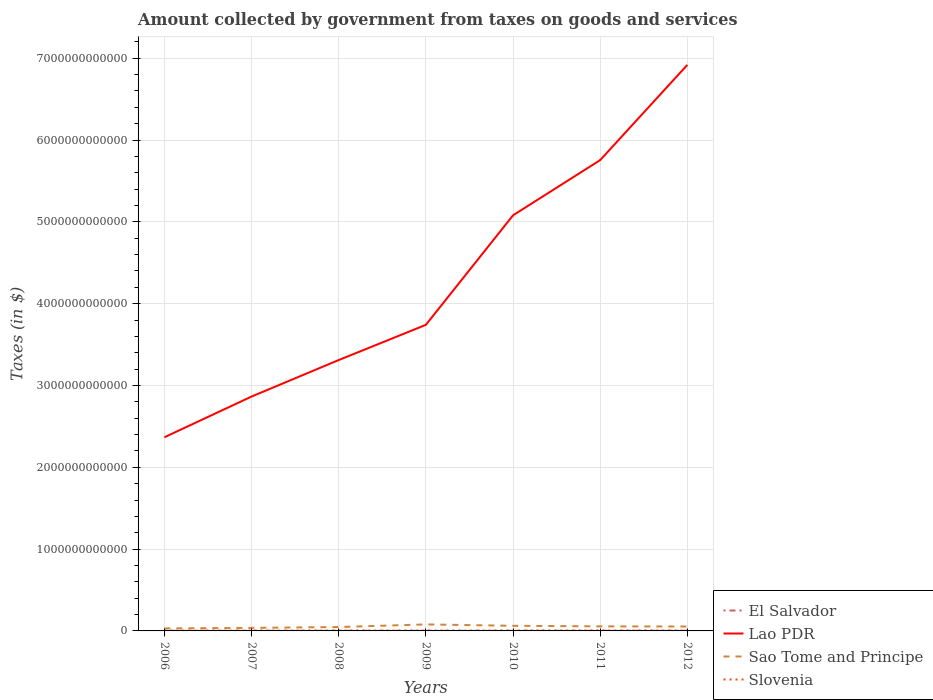How many different coloured lines are there?
Provide a short and direct response. 4. Does the line corresponding to Lao PDR intersect with the line corresponding to Slovenia?
Keep it short and to the point. No. Is the number of lines equal to the number of legend labels?
Your answer should be compact. Yes. Across all years, what is the maximum amount collected by government from taxes on goods and services in Slovenia?
Make the answer very short. 3.95e+09. What is the total amount collected by government from taxes on goods and services in Sao Tome and Principe in the graph?
Your answer should be compact. 2.57e+1. What is the difference between the highest and the second highest amount collected by government from taxes on goods and services in Slovenia?
Keep it short and to the point. 8.12e+08. How many lines are there?
Give a very brief answer. 4. How many years are there in the graph?
Keep it short and to the point. 7. What is the difference between two consecutive major ticks on the Y-axis?
Keep it short and to the point. 1.00e+12. Are the values on the major ticks of Y-axis written in scientific E-notation?
Your answer should be very brief. No. Does the graph contain any zero values?
Keep it short and to the point. No. Does the graph contain grids?
Make the answer very short. Yes. How many legend labels are there?
Your answer should be very brief. 4. What is the title of the graph?
Offer a terse response. Amount collected by government from taxes on goods and services. What is the label or title of the X-axis?
Your answer should be very brief. Years. What is the label or title of the Y-axis?
Keep it short and to the point. Taxes (in $). What is the Taxes (in $) in El Salvador in 2006?
Keep it short and to the point. 1.47e+09. What is the Taxes (in $) of Lao PDR in 2006?
Give a very brief answer. 2.37e+12. What is the Taxes (in $) in Sao Tome and Principe in 2006?
Your answer should be very brief. 3.05e+1. What is the Taxes (in $) in Slovenia in 2006?
Provide a succinct answer. 3.95e+09. What is the Taxes (in $) in El Salvador in 2007?
Offer a terse response. 1.66e+09. What is the Taxes (in $) in Lao PDR in 2007?
Your answer should be compact. 2.86e+12. What is the Taxes (in $) of Sao Tome and Principe in 2007?
Keep it short and to the point. 3.71e+1. What is the Taxes (in $) in Slovenia in 2007?
Your answer should be compact. 4.37e+09. What is the Taxes (in $) in El Salvador in 2008?
Make the answer very short. 1.80e+09. What is the Taxes (in $) in Lao PDR in 2008?
Keep it short and to the point. 3.31e+12. What is the Taxes (in $) in Sao Tome and Principe in 2008?
Give a very brief answer. 4.76e+1. What is the Taxes (in $) of Slovenia in 2008?
Offer a very short reply. 4.67e+09. What is the Taxes (in $) of El Salvador in 2009?
Keep it short and to the point. 1.44e+09. What is the Taxes (in $) in Lao PDR in 2009?
Give a very brief answer. 3.74e+12. What is the Taxes (in $) in Sao Tome and Principe in 2009?
Provide a succinct answer. 7.95e+1. What is the Taxes (in $) of Slovenia in 2009?
Your answer should be very brief. 4.54e+09. What is the Taxes (in $) of El Salvador in 2010?
Offer a very short reply. 1.66e+09. What is the Taxes (in $) of Lao PDR in 2010?
Keep it short and to the point. 5.08e+12. What is the Taxes (in $) of Sao Tome and Principe in 2010?
Provide a short and direct response. 6.27e+1. What is the Taxes (in $) of Slovenia in 2010?
Give a very brief answer. 4.66e+09. What is the Taxes (in $) of El Salvador in 2011?
Keep it short and to the point. 1.69e+09. What is the Taxes (in $) in Lao PDR in 2011?
Ensure brevity in your answer.  5.75e+12. What is the Taxes (in $) in Sao Tome and Principe in 2011?
Your answer should be compact. 5.56e+1. What is the Taxes (in $) of Slovenia in 2011?
Your answer should be very brief. 4.73e+09. What is the Taxes (in $) in El Salvador in 2012?
Your answer should be very brief. 2.09e+09. What is the Taxes (in $) of Lao PDR in 2012?
Give a very brief answer. 6.92e+12. What is the Taxes (in $) of Sao Tome and Principe in 2012?
Offer a very short reply. 5.38e+1. What is the Taxes (in $) of Slovenia in 2012?
Keep it short and to the point. 4.76e+09. Across all years, what is the maximum Taxes (in $) in El Salvador?
Your answer should be compact. 2.09e+09. Across all years, what is the maximum Taxes (in $) in Lao PDR?
Your answer should be compact. 6.92e+12. Across all years, what is the maximum Taxes (in $) of Sao Tome and Principe?
Your answer should be compact. 7.95e+1. Across all years, what is the maximum Taxes (in $) in Slovenia?
Your answer should be very brief. 4.76e+09. Across all years, what is the minimum Taxes (in $) in El Salvador?
Offer a very short reply. 1.44e+09. Across all years, what is the minimum Taxes (in $) of Lao PDR?
Your answer should be very brief. 2.37e+12. Across all years, what is the minimum Taxes (in $) of Sao Tome and Principe?
Offer a very short reply. 3.05e+1. Across all years, what is the minimum Taxes (in $) in Slovenia?
Your response must be concise. 3.95e+09. What is the total Taxes (in $) in El Salvador in the graph?
Provide a short and direct response. 1.18e+1. What is the total Taxes (in $) of Lao PDR in the graph?
Provide a short and direct response. 3.00e+13. What is the total Taxes (in $) in Sao Tome and Principe in the graph?
Provide a succinct answer. 3.67e+11. What is the total Taxes (in $) in Slovenia in the graph?
Provide a short and direct response. 3.17e+1. What is the difference between the Taxes (in $) of El Salvador in 2006 and that in 2007?
Ensure brevity in your answer.  -1.86e+08. What is the difference between the Taxes (in $) in Lao PDR in 2006 and that in 2007?
Provide a succinct answer. -4.98e+11. What is the difference between the Taxes (in $) in Sao Tome and Principe in 2006 and that in 2007?
Make the answer very short. -6.60e+09. What is the difference between the Taxes (in $) of Slovenia in 2006 and that in 2007?
Ensure brevity in your answer.  -4.23e+08. What is the difference between the Taxes (in $) of El Salvador in 2006 and that in 2008?
Your answer should be compact. -3.30e+08. What is the difference between the Taxes (in $) of Lao PDR in 2006 and that in 2008?
Your answer should be compact. -9.44e+11. What is the difference between the Taxes (in $) in Sao Tome and Principe in 2006 and that in 2008?
Offer a terse response. -1.71e+1. What is the difference between the Taxes (in $) of Slovenia in 2006 and that in 2008?
Your response must be concise. -7.19e+08. What is the difference between the Taxes (in $) of El Salvador in 2006 and that in 2009?
Offer a terse response. 3.19e+07. What is the difference between the Taxes (in $) in Lao PDR in 2006 and that in 2009?
Offer a very short reply. -1.37e+12. What is the difference between the Taxes (in $) of Sao Tome and Principe in 2006 and that in 2009?
Give a very brief answer. -4.90e+1. What is the difference between the Taxes (in $) in Slovenia in 2006 and that in 2009?
Your response must be concise. -5.92e+08. What is the difference between the Taxes (in $) of El Salvador in 2006 and that in 2010?
Give a very brief answer. -1.89e+08. What is the difference between the Taxes (in $) of Lao PDR in 2006 and that in 2010?
Keep it short and to the point. -2.71e+12. What is the difference between the Taxes (in $) in Sao Tome and Principe in 2006 and that in 2010?
Provide a short and direct response. -3.22e+1. What is the difference between the Taxes (in $) of Slovenia in 2006 and that in 2010?
Ensure brevity in your answer.  -7.09e+08. What is the difference between the Taxes (in $) of El Salvador in 2006 and that in 2011?
Provide a short and direct response. -2.21e+08. What is the difference between the Taxes (in $) of Lao PDR in 2006 and that in 2011?
Provide a short and direct response. -3.39e+12. What is the difference between the Taxes (in $) of Sao Tome and Principe in 2006 and that in 2011?
Your answer should be compact. -2.51e+1. What is the difference between the Taxes (in $) in Slovenia in 2006 and that in 2011?
Your answer should be very brief. -7.83e+08. What is the difference between the Taxes (in $) of El Salvador in 2006 and that in 2012?
Your answer should be very brief. -6.20e+08. What is the difference between the Taxes (in $) in Lao PDR in 2006 and that in 2012?
Ensure brevity in your answer.  -4.55e+12. What is the difference between the Taxes (in $) of Sao Tome and Principe in 2006 and that in 2012?
Offer a very short reply. -2.33e+1. What is the difference between the Taxes (in $) of Slovenia in 2006 and that in 2012?
Provide a succinct answer. -8.12e+08. What is the difference between the Taxes (in $) in El Salvador in 2007 and that in 2008?
Provide a short and direct response. -1.44e+08. What is the difference between the Taxes (in $) of Lao PDR in 2007 and that in 2008?
Keep it short and to the point. -4.46e+11. What is the difference between the Taxes (in $) of Sao Tome and Principe in 2007 and that in 2008?
Offer a terse response. -1.05e+1. What is the difference between the Taxes (in $) of Slovenia in 2007 and that in 2008?
Keep it short and to the point. -2.96e+08. What is the difference between the Taxes (in $) in El Salvador in 2007 and that in 2009?
Provide a short and direct response. 2.18e+08. What is the difference between the Taxes (in $) in Lao PDR in 2007 and that in 2009?
Keep it short and to the point. -8.77e+11. What is the difference between the Taxes (in $) of Sao Tome and Principe in 2007 and that in 2009?
Make the answer very short. -4.24e+1. What is the difference between the Taxes (in $) in Slovenia in 2007 and that in 2009?
Keep it short and to the point. -1.69e+08. What is the difference between the Taxes (in $) in El Salvador in 2007 and that in 2010?
Your response must be concise. -2.90e+06. What is the difference between the Taxes (in $) in Lao PDR in 2007 and that in 2010?
Provide a short and direct response. -2.22e+12. What is the difference between the Taxes (in $) of Sao Tome and Principe in 2007 and that in 2010?
Give a very brief answer. -2.56e+1. What is the difference between the Taxes (in $) in Slovenia in 2007 and that in 2010?
Your answer should be very brief. -2.86e+08. What is the difference between the Taxes (in $) in El Salvador in 2007 and that in 2011?
Keep it short and to the point. -3.50e+07. What is the difference between the Taxes (in $) in Lao PDR in 2007 and that in 2011?
Your response must be concise. -2.89e+12. What is the difference between the Taxes (in $) of Sao Tome and Principe in 2007 and that in 2011?
Your answer should be very brief. -1.85e+1. What is the difference between the Taxes (in $) of Slovenia in 2007 and that in 2011?
Make the answer very short. -3.60e+08. What is the difference between the Taxes (in $) in El Salvador in 2007 and that in 2012?
Make the answer very short. -4.34e+08. What is the difference between the Taxes (in $) in Lao PDR in 2007 and that in 2012?
Provide a short and direct response. -4.05e+12. What is the difference between the Taxes (in $) in Sao Tome and Principe in 2007 and that in 2012?
Ensure brevity in your answer.  -1.67e+1. What is the difference between the Taxes (in $) of Slovenia in 2007 and that in 2012?
Give a very brief answer. -3.89e+08. What is the difference between the Taxes (in $) of El Salvador in 2008 and that in 2009?
Give a very brief answer. 3.62e+08. What is the difference between the Taxes (in $) of Lao PDR in 2008 and that in 2009?
Provide a succinct answer. -4.30e+11. What is the difference between the Taxes (in $) of Sao Tome and Principe in 2008 and that in 2009?
Offer a very short reply. -3.19e+1. What is the difference between the Taxes (in $) of Slovenia in 2008 and that in 2009?
Provide a succinct answer. 1.27e+08. What is the difference between the Taxes (in $) of El Salvador in 2008 and that in 2010?
Keep it short and to the point. 1.41e+08. What is the difference between the Taxes (in $) in Lao PDR in 2008 and that in 2010?
Offer a very short reply. -1.77e+12. What is the difference between the Taxes (in $) of Sao Tome and Principe in 2008 and that in 2010?
Your response must be concise. -1.52e+1. What is the difference between the Taxes (in $) in Slovenia in 2008 and that in 2010?
Provide a succinct answer. 9.21e+06. What is the difference between the Taxes (in $) in El Salvador in 2008 and that in 2011?
Your answer should be compact. 1.09e+08. What is the difference between the Taxes (in $) of Lao PDR in 2008 and that in 2011?
Your response must be concise. -2.44e+12. What is the difference between the Taxes (in $) in Sao Tome and Principe in 2008 and that in 2011?
Offer a terse response. -8.04e+09. What is the difference between the Taxes (in $) in Slovenia in 2008 and that in 2011?
Offer a very short reply. -6.41e+07. What is the difference between the Taxes (in $) of El Salvador in 2008 and that in 2012?
Make the answer very short. -2.90e+08. What is the difference between the Taxes (in $) of Lao PDR in 2008 and that in 2012?
Your answer should be compact. -3.61e+12. What is the difference between the Taxes (in $) in Sao Tome and Principe in 2008 and that in 2012?
Offer a very short reply. -6.28e+09. What is the difference between the Taxes (in $) of Slovenia in 2008 and that in 2012?
Offer a very short reply. -9.32e+07. What is the difference between the Taxes (in $) of El Salvador in 2009 and that in 2010?
Make the answer very short. -2.20e+08. What is the difference between the Taxes (in $) in Lao PDR in 2009 and that in 2010?
Your answer should be compact. -1.34e+12. What is the difference between the Taxes (in $) in Sao Tome and Principe in 2009 and that in 2010?
Make the answer very short. 1.68e+1. What is the difference between the Taxes (in $) of Slovenia in 2009 and that in 2010?
Offer a terse response. -1.17e+08. What is the difference between the Taxes (in $) of El Salvador in 2009 and that in 2011?
Your answer should be very brief. -2.53e+08. What is the difference between the Taxes (in $) of Lao PDR in 2009 and that in 2011?
Your response must be concise. -2.01e+12. What is the difference between the Taxes (in $) in Sao Tome and Principe in 2009 and that in 2011?
Offer a very short reply. 2.39e+1. What is the difference between the Taxes (in $) of Slovenia in 2009 and that in 2011?
Keep it short and to the point. -1.91e+08. What is the difference between the Taxes (in $) in El Salvador in 2009 and that in 2012?
Offer a terse response. -6.52e+08. What is the difference between the Taxes (in $) in Lao PDR in 2009 and that in 2012?
Give a very brief answer. -3.18e+12. What is the difference between the Taxes (in $) in Sao Tome and Principe in 2009 and that in 2012?
Keep it short and to the point. 2.57e+1. What is the difference between the Taxes (in $) of Slovenia in 2009 and that in 2012?
Your answer should be very brief. -2.20e+08. What is the difference between the Taxes (in $) in El Salvador in 2010 and that in 2011?
Your answer should be very brief. -3.20e+07. What is the difference between the Taxes (in $) of Lao PDR in 2010 and that in 2011?
Offer a terse response. -6.75e+11. What is the difference between the Taxes (in $) of Sao Tome and Principe in 2010 and that in 2011?
Your answer should be very brief. 7.12e+09. What is the difference between the Taxes (in $) in Slovenia in 2010 and that in 2011?
Ensure brevity in your answer.  -7.33e+07. What is the difference between the Taxes (in $) in El Salvador in 2010 and that in 2012?
Keep it short and to the point. -4.32e+08. What is the difference between the Taxes (in $) in Lao PDR in 2010 and that in 2012?
Provide a succinct answer. -1.84e+12. What is the difference between the Taxes (in $) in Sao Tome and Principe in 2010 and that in 2012?
Make the answer very short. 8.88e+09. What is the difference between the Taxes (in $) in Slovenia in 2010 and that in 2012?
Give a very brief answer. -1.02e+08. What is the difference between the Taxes (in $) of El Salvador in 2011 and that in 2012?
Your response must be concise. -3.99e+08. What is the difference between the Taxes (in $) in Lao PDR in 2011 and that in 2012?
Your answer should be compact. -1.16e+12. What is the difference between the Taxes (in $) in Sao Tome and Principe in 2011 and that in 2012?
Offer a terse response. 1.76e+09. What is the difference between the Taxes (in $) of Slovenia in 2011 and that in 2012?
Provide a succinct answer. -2.91e+07. What is the difference between the Taxes (in $) of El Salvador in 2006 and the Taxes (in $) of Lao PDR in 2007?
Your response must be concise. -2.86e+12. What is the difference between the Taxes (in $) in El Salvador in 2006 and the Taxes (in $) in Sao Tome and Principe in 2007?
Keep it short and to the point. -3.56e+1. What is the difference between the Taxes (in $) in El Salvador in 2006 and the Taxes (in $) in Slovenia in 2007?
Your answer should be compact. -2.90e+09. What is the difference between the Taxes (in $) of Lao PDR in 2006 and the Taxes (in $) of Sao Tome and Principe in 2007?
Your answer should be compact. 2.33e+12. What is the difference between the Taxes (in $) of Lao PDR in 2006 and the Taxes (in $) of Slovenia in 2007?
Provide a short and direct response. 2.36e+12. What is the difference between the Taxes (in $) of Sao Tome and Principe in 2006 and the Taxes (in $) of Slovenia in 2007?
Your answer should be very brief. 2.61e+1. What is the difference between the Taxes (in $) in El Salvador in 2006 and the Taxes (in $) in Lao PDR in 2008?
Provide a short and direct response. -3.31e+12. What is the difference between the Taxes (in $) in El Salvador in 2006 and the Taxes (in $) in Sao Tome and Principe in 2008?
Provide a short and direct response. -4.61e+1. What is the difference between the Taxes (in $) in El Salvador in 2006 and the Taxes (in $) in Slovenia in 2008?
Provide a succinct answer. -3.20e+09. What is the difference between the Taxes (in $) in Lao PDR in 2006 and the Taxes (in $) in Sao Tome and Principe in 2008?
Your answer should be very brief. 2.32e+12. What is the difference between the Taxes (in $) of Lao PDR in 2006 and the Taxes (in $) of Slovenia in 2008?
Offer a terse response. 2.36e+12. What is the difference between the Taxes (in $) of Sao Tome and Principe in 2006 and the Taxes (in $) of Slovenia in 2008?
Provide a succinct answer. 2.58e+1. What is the difference between the Taxes (in $) in El Salvador in 2006 and the Taxes (in $) in Lao PDR in 2009?
Offer a very short reply. -3.74e+12. What is the difference between the Taxes (in $) in El Salvador in 2006 and the Taxes (in $) in Sao Tome and Principe in 2009?
Offer a terse response. -7.80e+1. What is the difference between the Taxes (in $) of El Salvador in 2006 and the Taxes (in $) of Slovenia in 2009?
Give a very brief answer. -3.07e+09. What is the difference between the Taxes (in $) of Lao PDR in 2006 and the Taxes (in $) of Sao Tome and Principe in 2009?
Your answer should be very brief. 2.29e+12. What is the difference between the Taxes (in $) of Lao PDR in 2006 and the Taxes (in $) of Slovenia in 2009?
Keep it short and to the point. 2.36e+12. What is the difference between the Taxes (in $) in Sao Tome and Principe in 2006 and the Taxes (in $) in Slovenia in 2009?
Give a very brief answer. 2.60e+1. What is the difference between the Taxes (in $) in El Salvador in 2006 and the Taxes (in $) in Lao PDR in 2010?
Ensure brevity in your answer.  -5.08e+12. What is the difference between the Taxes (in $) in El Salvador in 2006 and the Taxes (in $) in Sao Tome and Principe in 2010?
Make the answer very short. -6.13e+1. What is the difference between the Taxes (in $) in El Salvador in 2006 and the Taxes (in $) in Slovenia in 2010?
Keep it short and to the point. -3.19e+09. What is the difference between the Taxes (in $) of Lao PDR in 2006 and the Taxes (in $) of Sao Tome and Principe in 2010?
Offer a very short reply. 2.30e+12. What is the difference between the Taxes (in $) in Lao PDR in 2006 and the Taxes (in $) in Slovenia in 2010?
Make the answer very short. 2.36e+12. What is the difference between the Taxes (in $) of Sao Tome and Principe in 2006 and the Taxes (in $) of Slovenia in 2010?
Your answer should be compact. 2.58e+1. What is the difference between the Taxes (in $) in El Salvador in 2006 and the Taxes (in $) in Lao PDR in 2011?
Your response must be concise. -5.75e+12. What is the difference between the Taxes (in $) of El Salvador in 2006 and the Taxes (in $) of Sao Tome and Principe in 2011?
Your response must be concise. -5.41e+1. What is the difference between the Taxes (in $) in El Salvador in 2006 and the Taxes (in $) in Slovenia in 2011?
Make the answer very short. -3.26e+09. What is the difference between the Taxes (in $) in Lao PDR in 2006 and the Taxes (in $) in Sao Tome and Principe in 2011?
Give a very brief answer. 2.31e+12. What is the difference between the Taxes (in $) of Lao PDR in 2006 and the Taxes (in $) of Slovenia in 2011?
Make the answer very short. 2.36e+12. What is the difference between the Taxes (in $) of Sao Tome and Principe in 2006 and the Taxes (in $) of Slovenia in 2011?
Provide a short and direct response. 2.58e+1. What is the difference between the Taxes (in $) in El Salvador in 2006 and the Taxes (in $) in Lao PDR in 2012?
Ensure brevity in your answer.  -6.92e+12. What is the difference between the Taxes (in $) of El Salvador in 2006 and the Taxes (in $) of Sao Tome and Principe in 2012?
Provide a succinct answer. -5.24e+1. What is the difference between the Taxes (in $) in El Salvador in 2006 and the Taxes (in $) in Slovenia in 2012?
Your answer should be very brief. -3.29e+09. What is the difference between the Taxes (in $) of Lao PDR in 2006 and the Taxes (in $) of Sao Tome and Principe in 2012?
Offer a terse response. 2.31e+12. What is the difference between the Taxes (in $) in Lao PDR in 2006 and the Taxes (in $) in Slovenia in 2012?
Ensure brevity in your answer.  2.36e+12. What is the difference between the Taxes (in $) in Sao Tome and Principe in 2006 and the Taxes (in $) in Slovenia in 2012?
Give a very brief answer. 2.57e+1. What is the difference between the Taxes (in $) of El Salvador in 2007 and the Taxes (in $) of Lao PDR in 2008?
Your response must be concise. -3.31e+12. What is the difference between the Taxes (in $) in El Salvador in 2007 and the Taxes (in $) in Sao Tome and Principe in 2008?
Keep it short and to the point. -4.59e+1. What is the difference between the Taxes (in $) in El Salvador in 2007 and the Taxes (in $) in Slovenia in 2008?
Your answer should be compact. -3.01e+09. What is the difference between the Taxes (in $) of Lao PDR in 2007 and the Taxes (in $) of Sao Tome and Principe in 2008?
Make the answer very short. 2.82e+12. What is the difference between the Taxes (in $) in Lao PDR in 2007 and the Taxes (in $) in Slovenia in 2008?
Make the answer very short. 2.86e+12. What is the difference between the Taxes (in $) in Sao Tome and Principe in 2007 and the Taxes (in $) in Slovenia in 2008?
Your answer should be compact. 3.24e+1. What is the difference between the Taxes (in $) of El Salvador in 2007 and the Taxes (in $) of Lao PDR in 2009?
Offer a terse response. -3.74e+12. What is the difference between the Taxes (in $) in El Salvador in 2007 and the Taxes (in $) in Sao Tome and Principe in 2009?
Give a very brief answer. -7.78e+1. What is the difference between the Taxes (in $) of El Salvador in 2007 and the Taxes (in $) of Slovenia in 2009?
Offer a terse response. -2.88e+09. What is the difference between the Taxes (in $) of Lao PDR in 2007 and the Taxes (in $) of Sao Tome and Principe in 2009?
Provide a succinct answer. 2.78e+12. What is the difference between the Taxes (in $) in Lao PDR in 2007 and the Taxes (in $) in Slovenia in 2009?
Your response must be concise. 2.86e+12. What is the difference between the Taxes (in $) of Sao Tome and Principe in 2007 and the Taxes (in $) of Slovenia in 2009?
Offer a terse response. 3.26e+1. What is the difference between the Taxes (in $) in El Salvador in 2007 and the Taxes (in $) in Lao PDR in 2010?
Offer a very short reply. -5.08e+12. What is the difference between the Taxes (in $) of El Salvador in 2007 and the Taxes (in $) of Sao Tome and Principe in 2010?
Keep it short and to the point. -6.11e+1. What is the difference between the Taxes (in $) of El Salvador in 2007 and the Taxes (in $) of Slovenia in 2010?
Provide a short and direct response. -3.00e+09. What is the difference between the Taxes (in $) in Lao PDR in 2007 and the Taxes (in $) in Sao Tome and Principe in 2010?
Offer a very short reply. 2.80e+12. What is the difference between the Taxes (in $) in Lao PDR in 2007 and the Taxes (in $) in Slovenia in 2010?
Your response must be concise. 2.86e+12. What is the difference between the Taxes (in $) of Sao Tome and Principe in 2007 and the Taxes (in $) of Slovenia in 2010?
Give a very brief answer. 3.24e+1. What is the difference between the Taxes (in $) in El Salvador in 2007 and the Taxes (in $) in Lao PDR in 2011?
Your response must be concise. -5.75e+12. What is the difference between the Taxes (in $) of El Salvador in 2007 and the Taxes (in $) of Sao Tome and Principe in 2011?
Ensure brevity in your answer.  -5.39e+1. What is the difference between the Taxes (in $) of El Salvador in 2007 and the Taxes (in $) of Slovenia in 2011?
Your answer should be very brief. -3.08e+09. What is the difference between the Taxes (in $) in Lao PDR in 2007 and the Taxes (in $) in Sao Tome and Principe in 2011?
Offer a terse response. 2.81e+12. What is the difference between the Taxes (in $) in Lao PDR in 2007 and the Taxes (in $) in Slovenia in 2011?
Your answer should be compact. 2.86e+12. What is the difference between the Taxes (in $) in Sao Tome and Principe in 2007 and the Taxes (in $) in Slovenia in 2011?
Provide a short and direct response. 3.24e+1. What is the difference between the Taxes (in $) in El Salvador in 2007 and the Taxes (in $) in Lao PDR in 2012?
Provide a short and direct response. -6.92e+12. What is the difference between the Taxes (in $) of El Salvador in 2007 and the Taxes (in $) of Sao Tome and Principe in 2012?
Provide a short and direct response. -5.22e+1. What is the difference between the Taxes (in $) in El Salvador in 2007 and the Taxes (in $) in Slovenia in 2012?
Give a very brief answer. -3.10e+09. What is the difference between the Taxes (in $) of Lao PDR in 2007 and the Taxes (in $) of Sao Tome and Principe in 2012?
Offer a terse response. 2.81e+12. What is the difference between the Taxes (in $) in Lao PDR in 2007 and the Taxes (in $) in Slovenia in 2012?
Your response must be concise. 2.86e+12. What is the difference between the Taxes (in $) in Sao Tome and Principe in 2007 and the Taxes (in $) in Slovenia in 2012?
Your answer should be very brief. 3.23e+1. What is the difference between the Taxes (in $) in El Salvador in 2008 and the Taxes (in $) in Lao PDR in 2009?
Give a very brief answer. -3.74e+12. What is the difference between the Taxes (in $) in El Salvador in 2008 and the Taxes (in $) in Sao Tome and Principe in 2009?
Give a very brief answer. -7.77e+1. What is the difference between the Taxes (in $) of El Salvador in 2008 and the Taxes (in $) of Slovenia in 2009?
Your response must be concise. -2.74e+09. What is the difference between the Taxes (in $) in Lao PDR in 2008 and the Taxes (in $) in Sao Tome and Principe in 2009?
Your answer should be very brief. 3.23e+12. What is the difference between the Taxes (in $) of Lao PDR in 2008 and the Taxes (in $) of Slovenia in 2009?
Your answer should be compact. 3.31e+12. What is the difference between the Taxes (in $) of Sao Tome and Principe in 2008 and the Taxes (in $) of Slovenia in 2009?
Make the answer very short. 4.30e+1. What is the difference between the Taxes (in $) in El Salvador in 2008 and the Taxes (in $) in Lao PDR in 2010?
Offer a very short reply. -5.08e+12. What is the difference between the Taxes (in $) of El Salvador in 2008 and the Taxes (in $) of Sao Tome and Principe in 2010?
Provide a short and direct response. -6.09e+1. What is the difference between the Taxes (in $) of El Salvador in 2008 and the Taxes (in $) of Slovenia in 2010?
Give a very brief answer. -2.86e+09. What is the difference between the Taxes (in $) in Lao PDR in 2008 and the Taxes (in $) in Sao Tome and Principe in 2010?
Keep it short and to the point. 3.25e+12. What is the difference between the Taxes (in $) of Lao PDR in 2008 and the Taxes (in $) of Slovenia in 2010?
Your answer should be compact. 3.31e+12. What is the difference between the Taxes (in $) of Sao Tome and Principe in 2008 and the Taxes (in $) of Slovenia in 2010?
Offer a very short reply. 4.29e+1. What is the difference between the Taxes (in $) of El Salvador in 2008 and the Taxes (in $) of Lao PDR in 2011?
Give a very brief answer. -5.75e+12. What is the difference between the Taxes (in $) of El Salvador in 2008 and the Taxes (in $) of Sao Tome and Principe in 2011?
Your answer should be compact. -5.38e+1. What is the difference between the Taxes (in $) in El Salvador in 2008 and the Taxes (in $) in Slovenia in 2011?
Your answer should be very brief. -2.93e+09. What is the difference between the Taxes (in $) in Lao PDR in 2008 and the Taxes (in $) in Sao Tome and Principe in 2011?
Your answer should be compact. 3.26e+12. What is the difference between the Taxes (in $) of Lao PDR in 2008 and the Taxes (in $) of Slovenia in 2011?
Keep it short and to the point. 3.31e+12. What is the difference between the Taxes (in $) in Sao Tome and Principe in 2008 and the Taxes (in $) in Slovenia in 2011?
Provide a succinct answer. 4.28e+1. What is the difference between the Taxes (in $) in El Salvador in 2008 and the Taxes (in $) in Lao PDR in 2012?
Provide a short and direct response. -6.92e+12. What is the difference between the Taxes (in $) in El Salvador in 2008 and the Taxes (in $) in Sao Tome and Principe in 2012?
Ensure brevity in your answer.  -5.20e+1. What is the difference between the Taxes (in $) in El Salvador in 2008 and the Taxes (in $) in Slovenia in 2012?
Your answer should be very brief. -2.96e+09. What is the difference between the Taxes (in $) of Lao PDR in 2008 and the Taxes (in $) of Sao Tome and Principe in 2012?
Ensure brevity in your answer.  3.26e+12. What is the difference between the Taxes (in $) in Lao PDR in 2008 and the Taxes (in $) in Slovenia in 2012?
Make the answer very short. 3.31e+12. What is the difference between the Taxes (in $) of Sao Tome and Principe in 2008 and the Taxes (in $) of Slovenia in 2012?
Provide a short and direct response. 4.28e+1. What is the difference between the Taxes (in $) of El Salvador in 2009 and the Taxes (in $) of Lao PDR in 2010?
Give a very brief answer. -5.08e+12. What is the difference between the Taxes (in $) of El Salvador in 2009 and the Taxes (in $) of Sao Tome and Principe in 2010?
Keep it short and to the point. -6.13e+1. What is the difference between the Taxes (in $) in El Salvador in 2009 and the Taxes (in $) in Slovenia in 2010?
Your response must be concise. -3.22e+09. What is the difference between the Taxes (in $) of Lao PDR in 2009 and the Taxes (in $) of Sao Tome and Principe in 2010?
Provide a short and direct response. 3.68e+12. What is the difference between the Taxes (in $) of Lao PDR in 2009 and the Taxes (in $) of Slovenia in 2010?
Keep it short and to the point. 3.74e+12. What is the difference between the Taxes (in $) in Sao Tome and Principe in 2009 and the Taxes (in $) in Slovenia in 2010?
Provide a short and direct response. 7.48e+1. What is the difference between the Taxes (in $) in El Salvador in 2009 and the Taxes (in $) in Lao PDR in 2011?
Keep it short and to the point. -5.75e+12. What is the difference between the Taxes (in $) in El Salvador in 2009 and the Taxes (in $) in Sao Tome and Principe in 2011?
Offer a very short reply. -5.42e+1. What is the difference between the Taxes (in $) of El Salvador in 2009 and the Taxes (in $) of Slovenia in 2011?
Offer a very short reply. -3.29e+09. What is the difference between the Taxes (in $) of Lao PDR in 2009 and the Taxes (in $) of Sao Tome and Principe in 2011?
Offer a terse response. 3.69e+12. What is the difference between the Taxes (in $) in Lao PDR in 2009 and the Taxes (in $) in Slovenia in 2011?
Provide a succinct answer. 3.74e+12. What is the difference between the Taxes (in $) in Sao Tome and Principe in 2009 and the Taxes (in $) in Slovenia in 2011?
Offer a very short reply. 7.48e+1. What is the difference between the Taxes (in $) of El Salvador in 2009 and the Taxes (in $) of Lao PDR in 2012?
Provide a short and direct response. -6.92e+12. What is the difference between the Taxes (in $) of El Salvador in 2009 and the Taxes (in $) of Sao Tome and Principe in 2012?
Offer a very short reply. -5.24e+1. What is the difference between the Taxes (in $) in El Salvador in 2009 and the Taxes (in $) in Slovenia in 2012?
Your answer should be compact. -3.32e+09. What is the difference between the Taxes (in $) in Lao PDR in 2009 and the Taxes (in $) in Sao Tome and Principe in 2012?
Ensure brevity in your answer.  3.69e+12. What is the difference between the Taxes (in $) in Lao PDR in 2009 and the Taxes (in $) in Slovenia in 2012?
Offer a very short reply. 3.74e+12. What is the difference between the Taxes (in $) in Sao Tome and Principe in 2009 and the Taxes (in $) in Slovenia in 2012?
Keep it short and to the point. 7.47e+1. What is the difference between the Taxes (in $) in El Salvador in 2010 and the Taxes (in $) in Lao PDR in 2011?
Give a very brief answer. -5.75e+12. What is the difference between the Taxes (in $) of El Salvador in 2010 and the Taxes (in $) of Sao Tome and Principe in 2011?
Provide a short and direct response. -5.39e+1. What is the difference between the Taxes (in $) of El Salvador in 2010 and the Taxes (in $) of Slovenia in 2011?
Your answer should be compact. -3.07e+09. What is the difference between the Taxes (in $) of Lao PDR in 2010 and the Taxes (in $) of Sao Tome and Principe in 2011?
Offer a very short reply. 5.02e+12. What is the difference between the Taxes (in $) of Lao PDR in 2010 and the Taxes (in $) of Slovenia in 2011?
Provide a short and direct response. 5.07e+12. What is the difference between the Taxes (in $) of Sao Tome and Principe in 2010 and the Taxes (in $) of Slovenia in 2011?
Offer a terse response. 5.80e+1. What is the difference between the Taxes (in $) in El Salvador in 2010 and the Taxes (in $) in Lao PDR in 2012?
Ensure brevity in your answer.  -6.92e+12. What is the difference between the Taxes (in $) of El Salvador in 2010 and the Taxes (in $) of Sao Tome and Principe in 2012?
Offer a very short reply. -5.22e+1. What is the difference between the Taxes (in $) in El Salvador in 2010 and the Taxes (in $) in Slovenia in 2012?
Provide a short and direct response. -3.10e+09. What is the difference between the Taxes (in $) in Lao PDR in 2010 and the Taxes (in $) in Sao Tome and Principe in 2012?
Your response must be concise. 5.03e+12. What is the difference between the Taxes (in $) in Lao PDR in 2010 and the Taxes (in $) in Slovenia in 2012?
Offer a very short reply. 5.07e+12. What is the difference between the Taxes (in $) of Sao Tome and Principe in 2010 and the Taxes (in $) of Slovenia in 2012?
Offer a very short reply. 5.80e+1. What is the difference between the Taxes (in $) in El Salvador in 2011 and the Taxes (in $) in Lao PDR in 2012?
Offer a very short reply. -6.92e+12. What is the difference between the Taxes (in $) of El Salvador in 2011 and the Taxes (in $) of Sao Tome and Principe in 2012?
Offer a terse response. -5.22e+1. What is the difference between the Taxes (in $) in El Salvador in 2011 and the Taxes (in $) in Slovenia in 2012?
Ensure brevity in your answer.  -3.07e+09. What is the difference between the Taxes (in $) in Lao PDR in 2011 and the Taxes (in $) in Sao Tome and Principe in 2012?
Your response must be concise. 5.70e+12. What is the difference between the Taxes (in $) in Lao PDR in 2011 and the Taxes (in $) in Slovenia in 2012?
Make the answer very short. 5.75e+12. What is the difference between the Taxes (in $) in Sao Tome and Principe in 2011 and the Taxes (in $) in Slovenia in 2012?
Your answer should be compact. 5.08e+1. What is the average Taxes (in $) in El Salvador per year?
Make the answer very short. 1.69e+09. What is the average Taxes (in $) of Lao PDR per year?
Give a very brief answer. 4.29e+12. What is the average Taxes (in $) in Sao Tome and Principe per year?
Keep it short and to the point. 5.24e+1. What is the average Taxes (in $) in Slovenia per year?
Provide a succinct answer. 4.53e+09. In the year 2006, what is the difference between the Taxes (in $) in El Salvador and Taxes (in $) in Lao PDR?
Make the answer very short. -2.37e+12. In the year 2006, what is the difference between the Taxes (in $) of El Salvador and Taxes (in $) of Sao Tome and Principe?
Your answer should be compact. -2.90e+1. In the year 2006, what is the difference between the Taxes (in $) of El Salvador and Taxes (in $) of Slovenia?
Offer a terse response. -2.48e+09. In the year 2006, what is the difference between the Taxes (in $) in Lao PDR and Taxes (in $) in Sao Tome and Principe?
Your answer should be compact. 2.34e+12. In the year 2006, what is the difference between the Taxes (in $) in Lao PDR and Taxes (in $) in Slovenia?
Your answer should be compact. 2.36e+12. In the year 2006, what is the difference between the Taxes (in $) in Sao Tome and Principe and Taxes (in $) in Slovenia?
Provide a short and direct response. 2.66e+1. In the year 2007, what is the difference between the Taxes (in $) in El Salvador and Taxes (in $) in Lao PDR?
Keep it short and to the point. -2.86e+12. In the year 2007, what is the difference between the Taxes (in $) in El Salvador and Taxes (in $) in Sao Tome and Principe?
Your answer should be very brief. -3.54e+1. In the year 2007, what is the difference between the Taxes (in $) in El Salvador and Taxes (in $) in Slovenia?
Offer a very short reply. -2.72e+09. In the year 2007, what is the difference between the Taxes (in $) of Lao PDR and Taxes (in $) of Sao Tome and Principe?
Your response must be concise. 2.83e+12. In the year 2007, what is the difference between the Taxes (in $) of Lao PDR and Taxes (in $) of Slovenia?
Your answer should be very brief. 2.86e+12. In the year 2007, what is the difference between the Taxes (in $) in Sao Tome and Principe and Taxes (in $) in Slovenia?
Offer a very short reply. 3.27e+1. In the year 2008, what is the difference between the Taxes (in $) of El Salvador and Taxes (in $) of Lao PDR?
Offer a very short reply. -3.31e+12. In the year 2008, what is the difference between the Taxes (in $) of El Salvador and Taxes (in $) of Sao Tome and Principe?
Your response must be concise. -4.58e+1. In the year 2008, what is the difference between the Taxes (in $) in El Salvador and Taxes (in $) in Slovenia?
Your answer should be very brief. -2.87e+09. In the year 2008, what is the difference between the Taxes (in $) of Lao PDR and Taxes (in $) of Sao Tome and Principe?
Offer a very short reply. 3.26e+12. In the year 2008, what is the difference between the Taxes (in $) of Lao PDR and Taxes (in $) of Slovenia?
Your answer should be very brief. 3.31e+12. In the year 2008, what is the difference between the Taxes (in $) in Sao Tome and Principe and Taxes (in $) in Slovenia?
Give a very brief answer. 4.29e+1. In the year 2009, what is the difference between the Taxes (in $) in El Salvador and Taxes (in $) in Lao PDR?
Ensure brevity in your answer.  -3.74e+12. In the year 2009, what is the difference between the Taxes (in $) of El Salvador and Taxes (in $) of Sao Tome and Principe?
Make the answer very short. -7.81e+1. In the year 2009, what is the difference between the Taxes (in $) in El Salvador and Taxes (in $) in Slovenia?
Offer a very short reply. -3.10e+09. In the year 2009, what is the difference between the Taxes (in $) of Lao PDR and Taxes (in $) of Sao Tome and Principe?
Offer a very short reply. 3.66e+12. In the year 2009, what is the difference between the Taxes (in $) in Lao PDR and Taxes (in $) in Slovenia?
Provide a short and direct response. 3.74e+12. In the year 2009, what is the difference between the Taxes (in $) of Sao Tome and Principe and Taxes (in $) of Slovenia?
Give a very brief answer. 7.50e+1. In the year 2010, what is the difference between the Taxes (in $) in El Salvador and Taxes (in $) in Lao PDR?
Give a very brief answer. -5.08e+12. In the year 2010, what is the difference between the Taxes (in $) of El Salvador and Taxes (in $) of Sao Tome and Principe?
Your answer should be very brief. -6.11e+1. In the year 2010, what is the difference between the Taxes (in $) in El Salvador and Taxes (in $) in Slovenia?
Your answer should be compact. -3.00e+09. In the year 2010, what is the difference between the Taxes (in $) of Lao PDR and Taxes (in $) of Sao Tome and Principe?
Keep it short and to the point. 5.02e+12. In the year 2010, what is the difference between the Taxes (in $) in Lao PDR and Taxes (in $) in Slovenia?
Make the answer very short. 5.08e+12. In the year 2010, what is the difference between the Taxes (in $) in Sao Tome and Principe and Taxes (in $) in Slovenia?
Offer a terse response. 5.81e+1. In the year 2011, what is the difference between the Taxes (in $) of El Salvador and Taxes (in $) of Lao PDR?
Offer a very short reply. -5.75e+12. In the year 2011, what is the difference between the Taxes (in $) of El Salvador and Taxes (in $) of Sao Tome and Principe?
Offer a terse response. -5.39e+1. In the year 2011, what is the difference between the Taxes (in $) of El Salvador and Taxes (in $) of Slovenia?
Your answer should be very brief. -3.04e+09. In the year 2011, what is the difference between the Taxes (in $) in Lao PDR and Taxes (in $) in Sao Tome and Principe?
Your answer should be compact. 5.70e+12. In the year 2011, what is the difference between the Taxes (in $) in Lao PDR and Taxes (in $) in Slovenia?
Offer a very short reply. 5.75e+12. In the year 2011, what is the difference between the Taxes (in $) of Sao Tome and Principe and Taxes (in $) of Slovenia?
Provide a succinct answer. 5.09e+1. In the year 2012, what is the difference between the Taxes (in $) in El Salvador and Taxes (in $) in Lao PDR?
Your answer should be very brief. -6.92e+12. In the year 2012, what is the difference between the Taxes (in $) in El Salvador and Taxes (in $) in Sao Tome and Principe?
Give a very brief answer. -5.18e+1. In the year 2012, what is the difference between the Taxes (in $) of El Salvador and Taxes (in $) of Slovenia?
Your answer should be compact. -2.67e+09. In the year 2012, what is the difference between the Taxes (in $) in Lao PDR and Taxes (in $) in Sao Tome and Principe?
Provide a short and direct response. 6.86e+12. In the year 2012, what is the difference between the Taxes (in $) in Lao PDR and Taxes (in $) in Slovenia?
Provide a short and direct response. 6.91e+12. In the year 2012, what is the difference between the Taxes (in $) of Sao Tome and Principe and Taxes (in $) of Slovenia?
Your answer should be compact. 4.91e+1. What is the ratio of the Taxes (in $) of El Salvador in 2006 to that in 2007?
Ensure brevity in your answer.  0.89. What is the ratio of the Taxes (in $) of Lao PDR in 2006 to that in 2007?
Your answer should be very brief. 0.83. What is the ratio of the Taxes (in $) in Sao Tome and Principe in 2006 to that in 2007?
Your answer should be compact. 0.82. What is the ratio of the Taxes (in $) in Slovenia in 2006 to that in 2007?
Your response must be concise. 0.9. What is the ratio of the Taxes (in $) of El Salvador in 2006 to that in 2008?
Provide a succinct answer. 0.82. What is the ratio of the Taxes (in $) of Lao PDR in 2006 to that in 2008?
Offer a terse response. 0.71. What is the ratio of the Taxes (in $) in Sao Tome and Principe in 2006 to that in 2008?
Ensure brevity in your answer.  0.64. What is the ratio of the Taxes (in $) in Slovenia in 2006 to that in 2008?
Offer a very short reply. 0.85. What is the ratio of the Taxes (in $) of El Salvador in 2006 to that in 2009?
Offer a very short reply. 1.02. What is the ratio of the Taxes (in $) in Lao PDR in 2006 to that in 2009?
Your response must be concise. 0.63. What is the ratio of the Taxes (in $) of Sao Tome and Principe in 2006 to that in 2009?
Ensure brevity in your answer.  0.38. What is the ratio of the Taxes (in $) in Slovenia in 2006 to that in 2009?
Your response must be concise. 0.87. What is the ratio of the Taxes (in $) of El Salvador in 2006 to that in 2010?
Your answer should be compact. 0.89. What is the ratio of the Taxes (in $) of Lao PDR in 2006 to that in 2010?
Provide a short and direct response. 0.47. What is the ratio of the Taxes (in $) of Sao Tome and Principe in 2006 to that in 2010?
Keep it short and to the point. 0.49. What is the ratio of the Taxes (in $) of Slovenia in 2006 to that in 2010?
Your response must be concise. 0.85. What is the ratio of the Taxes (in $) in El Salvador in 2006 to that in 2011?
Provide a succinct answer. 0.87. What is the ratio of the Taxes (in $) in Lao PDR in 2006 to that in 2011?
Keep it short and to the point. 0.41. What is the ratio of the Taxes (in $) in Sao Tome and Principe in 2006 to that in 2011?
Provide a succinct answer. 0.55. What is the ratio of the Taxes (in $) in Slovenia in 2006 to that in 2011?
Make the answer very short. 0.83. What is the ratio of the Taxes (in $) in El Salvador in 2006 to that in 2012?
Provide a short and direct response. 0.7. What is the ratio of the Taxes (in $) in Lao PDR in 2006 to that in 2012?
Provide a succinct answer. 0.34. What is the ratio of the Taxes (in $) of Sao Tome and Principe in 2006 to that in 2012?
Provide a short and direct response. 0.57. What is the ratio of the Taxes (in $) in Slovenia in 2006 to that in 2012?
Make the answer very short. 0.83. What is the ratio of the Taxes (in $) in El Salvador in 2007 to that in 2008?
Offer a terse response. 0.92. What is the ratio of the Taxes (in $) in Lao PDR in 2007 to that in 2008?
Give a very brief answer. 0.87. What is the ratio of the Taxes (in $) in Sao Tome and Principe in 2007 to that in 2008?
Ensure brevity in your answer.  0.78. What is the ratio of the Taxes (in $) of Slovenia in 2007 to that in 2008?
Offer a very short reply. 0.94. What is the ratio of the Taxes (in $) of El Salvador in 2007 to that in 2009?
Make the answer very short. 1.15. What is the ratio of the Taxes (in $) in Lao PDR in 2007 to that in 2009?
Offer a terse response. 0.77. What is the ratio of the Taxes (in $) of Sao Tome and Principe in 2007 to that in 2009?
Your response must be concise. 0.47. What is the ratio of the Taxes (in $) in Slovenia in 2007 to that in 2009?
Your response must be concise. 0.96. What is the ratio of the Taxes (in $) of Lao PDR in 2007 to that in 2010?
Offer a very short reply. 0.56. What is the ratio of the Taxes (in $) of Sao Tome and Principe in 2007 to that in 2010?
Keep it short and to the point. 0.59. What is the ratio of the Taxes (in $) of Slovenia in 2007 to that in 2010?
Your answer should be very brief. 0.94. What is the ratio of the Taxes (in $) of El Salvador in 2007 to that in 2011?
Your answer should be compact. 0.98. What is the ratio of the Taxes (in $) in Lao PDR in 2007 to that in 2011?
Your answer should be compact. 0.5. What is the ratio of the Taxes (in $) in Sao Tome and Principe in 2007 to that in 2011?
Ensure brevity in your answer.  0.67. What is the ratio of the Taxes (in $) in Slovenia in 2007 to that in 2011?
Ensure brevity in your answer.  0.92. What is the ratio of the Taxes (in $) in El Salvador in 2007 to that in 2012?
Offer a terse response. 0.79. What is the ratio of the Taxes (in $) in Lao PDR in 2007 to that in 2012?
Your answer should be compact. 0.41. What is the ratio of the Taxes (in $) in Sao Tome and Principe in 2007 to that in 2012?
Offer a very short reply. 0.69. What is the ratio of the Taxes (in $) in Slovenia in 2007 to that in 2012?
Your response must be concise. 0.92. What is the ratio of the Taxes (in $) in El Salvador in 2008 to that in 2009?
Your answer should be compact. 1.25. What is the ratio of the Taxes (in $) of Lao PDR in 2008 to that in 2009?
Keep it short and to the point. 0.89. What is the ratio of the Taxes (in $) in Sao Tome and Principe in 2008 to that in 2009?
Your answer should be very brief. 0.6. What is the ratio of the Taxes (in $) in Slovenia in 2008 to that in 2009?
Ensure brevity in your answer.  1.03. What is the ratio of the Taxes (in $) of El Salvador in 2008 to that in 2010?
Your answer should be compact. 1.09. What is the ratio of the Taxes (in $) in Lao PDR in 2008 to that in 2010?
Give a very brief answer. 0.65. What is the ratio of the Taxes (in $) in Sao Tome and Principe in 2008 to that in 2010?
Keep it short and to the point. 0.76. What is the ratio of the Taxes (in $) of El Salvador in 2008 to that in 2011?
Offer a terse response. 1.06. What is the ratio of the Taxes (in $) of Lao PDR in 2008 to that in 2011?
Your answer should be compact. 0.58. What is the ratio of the Taxes (in $) in Sao Tome and Principe in 2008 to that in 2011?
Provide a succinct answer. 0.86. What is the ratio of the Taxes (in $) in Slovenia in 2008 to that in 2011?
Offer a very short reply. 0.99. What is the ratio of the Taxes (in $) of El Salvador in 2008 to that in 2012?
Your answer should be very brief. 0.86. What is the ratio of the Taxes (in $) of Lao PDR in 2008 to that in 2012?
Your answer should be very brief. 0.48. What is the ratio of the Taxes (in $) in Sao Tome and Principe in 2008 to that in 2012?
Give a very brief answer. 0.88. What is the ratio of the Taxes (in $) in Slovenia in 2008 to that in 2012?
Ensure brevity in your answer.  0.98. What is the ratio of the Taxes (in $) of El Salvador in 2009 to that in 2010?
Provide a succinct answer. 0.87. What is the ratio of the Taxes (in $) of Lao PDR in 2009 to that in 2010?
Your response must be concise. 0.74. What is the ratio of the Taxes (in $) in Sao Tome and Principe in 2009 to that in 2010?
Make the answer very short. 1.27. What is the ratio of the Taxes (in $) of Slovenia in 2009 to that in 2010?
Keep it short and to the point. 0.97. What is the ratio of the Taxes (in $) of El Salvador in 2009 to that in 2011?
Your answer should be compact. 0.85. What is the ratio of the Taxes (in $) of Lao PDR in 2009 to that in 2011?
Your answer should be very brief. 0.65. What is the ratio of the Taxes (in $) in Sao Tome and Principe in 2009 to that in 2011?
Your answer should be very brief. 1.43. What is the ratio of the Taxes (in $) in Slovenia in 2009 to that in 2011?
Provide a short and direct response. 0.96. What is the ratio of the Taxes (in $) of El Salvador in 2009 to that in 2012?
Offer a very short reply. 0.69. What is the ratio of the Taxes (in $) of Lao PDR in 2009 to that in 2012?
Keep it short and to the point. 0.54. What is the ratio of the Taxes (in $) in Sao Tome and Principe in 2009 to that in 2012?
Give a very brief answer. 1.48. What is the ratio of the Taxes (in $) of Slovenia in 2009 to that in 2012?
Your answer should be very brief. 0.95. What is the ratio of the Taxes (in $) in El Salvador in 2010 to that in 2011?
Give a very brief answer. 0.98. What is the ratio of the Taxes (in $) in Lao PDR in 2010 to that in 2011?
Offer a very short reply. 0.88. What is the ratio of the Taxes (in $) of Sao Tome and Principe in 2010 to that in 2011?
Give a very brief answer. 1.13. What is the ratio of the Taxes (in $) in Slovenia in 2010 to that in 2011?
Make the answer very short. 0.98. What is the ratio of the Taxes (in $) in El Salvador in 2010 to that in 2012?
Your response must be concise. 0.79. What is the ratio of the Taxes (in $) in Lao PDR in 2010 to that in 2012?
Ensure brevity in your answer.  0.73. What is the ratio of the Taxes (in $) of Sao Tome and Principe in 2010 to that in 2012?
Ensure brevity in your answer.  1.16. What is the ratio of the Taxes (in $) of Slovenia in 2010 to that in 2012?
Make the answer very short. 0.98. What is the ratio of the Taxes (in $) in El Salvador in 2011 to that in 2012?
Make the answer very short. 0.81. What is the ratio of the Taxes (in $) in Lao PDR in 2011 to that in 2012?
Provide a succinct answer. 0.83. What is the ratio of the Taxes (in $) of Sao Tome and Principe in 2011 to that in 2012?
Ensure brevity in your answer.  1.03. What is the difference between the highest and the second highest Taxes (in $) in El Salvador?
Make the answer very short. 2.90e+08. What is the difference between the highest and the second highest Taxes (in $) of Lao PDR?
Keep it short and to the point. 1.16e+12. What is the difference between the highest and the second highest Taxes (in $) of Sao Tome and Principe?
Your answer should be very brief. 1.68e+1. What is the difference between the highest and the second highest Taxes (in $) in Slovenia?
Provide a short and direct response. 2.91e+07. What is the difference between the highest and the lowest Taxes (in $) in El Salvador?
Your response must be concise. 6.52e+08. What is the difference between the highest and the lowest Taxes (in $) of Lao PDR?
Provide a short and direct response. 4.55e+12. What is the difference between the highest and the lowest Taxes (in $) in Sao Tome and Principe?
Provide a short and direct response. 4.90e+1. What is the difference between the highest and the lowest Taxes (in $) in Slovenia?
Provide a short and direct response. 8.12e+08. 